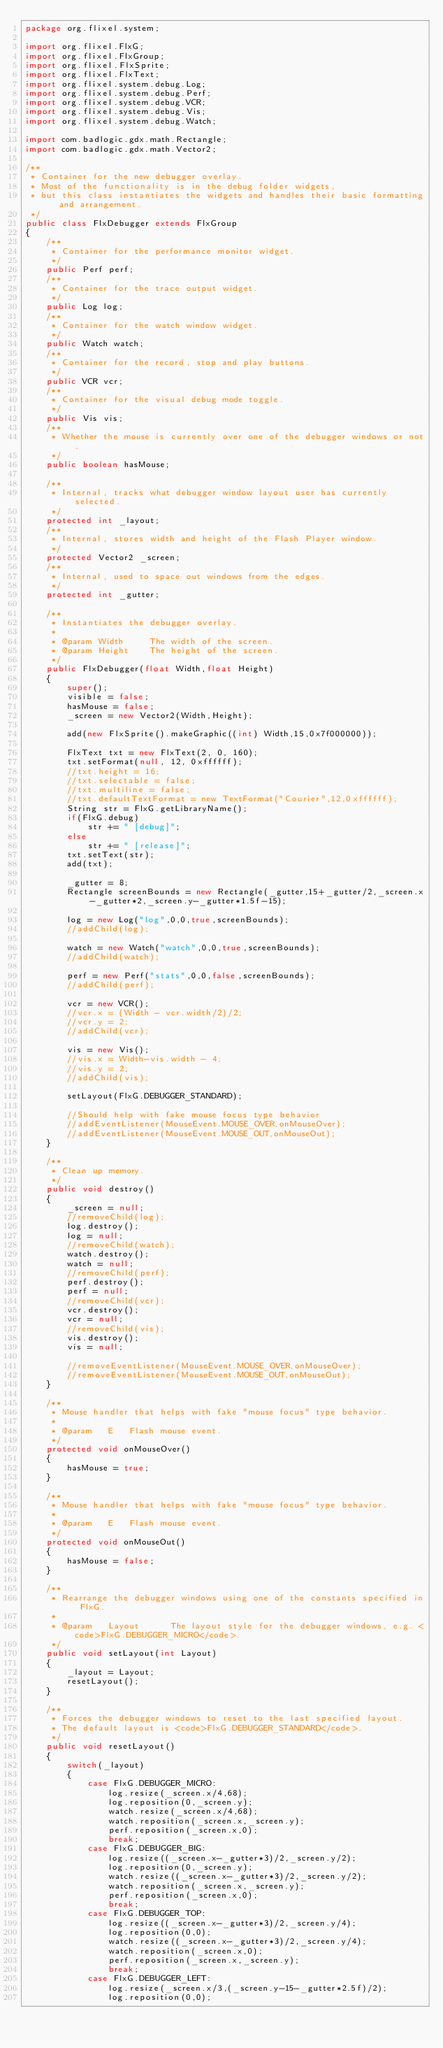Convert code to text. <code><loc_0><loc_0><loc_500><loc_500><_Java_>package org.flixel.system;

import org.flixel.FlxG;
import org.flixel.FlxGroup;
import org.flixel.FlxSprite;
import org.flixel.FlxText;
import org.flixel.system.debug.Log;
import org.flixel.system.debug.Perf;
import org.flixel.system.debug.VCR;
import org.flixel.system.debug.Vis;
import org.flixel.system.debug.Watch;

import com.badlogic.gdx.math.Rectangle;
import com.badlogic.gdx.math.Vector2;

/**
 * Container for the new debugger overlay.
 * Most of the functionality is in the debug folder widgets,
 * but this class instantiates the widgets and handles their basic formatting and arrangement.
 */
public class FlxDebugger extends FlxGroup
{
	/**
	 * Container for the performance monitor widget.
	 */
	public Perf perf;
	/**
	 * Container for the trace output widget.
	 */
	public Log log;
	/**
	 * Container for the watch window widget.
	 */
	public Watch watch;
	/**
	 * Container for the record, stop and play buttons.
	 */
	public VCR vcr;
	/**
	 * Container for the visual debug mode toggle.
	 */
	public Vis vis;
	/**
	 * Whether the mouse is currently over one of the debugger windows or not.
	 */
	public boolean hasMouse;
	
	/**
	 * Internal, tracks what debugger window layout user has currently selected.
	 */
	protected int _layout;
	/**
	 * Internal, stores width and height of the Flash Player window.
	 */
	protected Vector2 _screen;
	/**
	 * Internal, used to space out windows from the edges.
	 */
	protected int _gutter;

	/**
	 * Instantiates the debugger overlay.
	 * 
	 * @param Width		The width of the screen.
	 * @param Height	The height of the screen.
	 */
	public FlxDebugger(float Width,float Height)
	{
		super();
		visible = false;
		hasMouse = false;
		_screen = new Vector2(Width,Height);

		add(new FlxSprite().makeGraphic((int) Width,15,0x7f000000));

		FlxText txt = new FlxText(2, 0, 160);
		txt.setFormat(null, 12, 0xffffff);
		//txt.height = 16;
		//txt.selectable = false;
		//txt.multiline = false;
		//txt.defaultTextFormat = new TextFormat("Courier",12,0xffffff);
		String str = FlxG.getLibraryName();
		if(FlxG.debug)
			str += " [debug]";
		else
			str += " [release]";
		txt.setText(str);
		add(txt);

		_gutter = 8;
		Rectangle screenBounds = new Rectangle(_gutter,15+_gutter/2,_screen.x-_gutter*2,_screen.y-_gutter*1.5f-15);

		log = new Log("log",0,0,true,screenBounds);
		//addChild(log);

		watch = new Watch("watch",0,0,true,screenBounds);
		//addChild(watch);

		perf = new Perf("stats",0,0,false,screenBounds);
		//addChild(perf);

		vcr = new VCR();
		//vcr.x = (Width - vcr.width/2)/2;
		//vcr.y = 2;
		//addChild(vcr);

		vis = new Vis();
		//vis.x = Width-vis.width - 4;
		//vis.y = 2;
		//addChild(vis);

		setLayout(FlxG.DEBUGGER_STANDARD);

		//Should help with fake mouse focus type behavior
		//addEventListener(MouseEvent.MOUSE_OVER,onMouseOver);
		//addEventListener(MouseEvent.MOUSE_OUT,onMouseOut);
	}

	/**
	 * Clean up memory.
	 */
	public void destroy()
	{
		_screen = null;
		//removeChild(log);
		log.destroy();
		log = null;
		//removeChild(watch);
		watch.destroy();
		watch = null;
		//removeChild(perf);
		perf.destroy();
		perf = null;
		//removeChild(vcr);
		vcr.destroy();
		vcr = null;
		//removeChild(vis);
		vis.destroy();
		vis = null;

		//removeEventListener(MouseEvent.MOUSE_OVER,onMouseOver);
		//removeEventListener(MouseEvent.MOUSE_OUT,onMouseOut);
	}

	/**
	 * Mouse handler that helps with fake "mouse focus" type behavior.
	 * 
	 * @param	E	Flash mouse event.
	 */
	protected void onMouseOver()
	{
		hasMouse = true;
	}

	/**
	 * Mouse handler that helps with fake "mouse focus" type behavior.
	 * 
	 * @param	E	Flash mouse event.
	 */
	protected void onMouseOut()
	{
		hasMouse = false;
	}

	/**
	 * Rearrange the debugger windows using one of the constants specified in FlxG.
	 * 
	 * @param	Layout		The layout style for the debugger windows, e.g. <code>FlxG.DEBUGGER_MICRO</code>.
	 */
	public void setLayout(int Layout)
	{
		_layout = Layout;
		resetLayout();
	}

	/**
	 * Forces the debugger windows to reset to the last specified layout.
	 * The default layout is <code>FlxG.DEBUGGER_STANDARD</code>.
	 */
	public void resetLayout()
	{
		switch(_layout)
		{
			case FlxG.DEBUGGER_MICRO:
				log.resize(_screen.x/4,68);
				log.reposition(0,_screen.y);
				watch.resize(_screen.x/4,68);
				watch.reposition(_screen.x,_screen.y);
				perf.reposition(_screen.x,0);
				break;
			case FlxG.DEBUGGER_BIG:
				log.resize((_screen.x-_gutter*3)/2,_screen.y/2);
				log.reposition(0,_screen.y);
				watch.resize((_screen.x-_gutter*3)/2,_screen.y/2);
				watch.reposition(_screen.x,_screen.y);
				perf.reposition(_screen.x,0);
				break;
			case FlxG.DEBUGGER_TOP:
				log.resize((_screen.x-_gutter*3)/2,_screen.y/4);
				log.reposition(0,0);
				watch.resize((_screen.x-_gutter*3)/2,_screen.y/4);
				watch.reposition(_screen.x,0);
				perf.reposition(_screen.x,_screen.y);
				break;
			case FlxG.DEBUGGER_LEFT:
				log.resize(_screen.x/3,(_screen.y-15-_gutter*2.5f)/2);
				log.reposition(0,0);</code> 